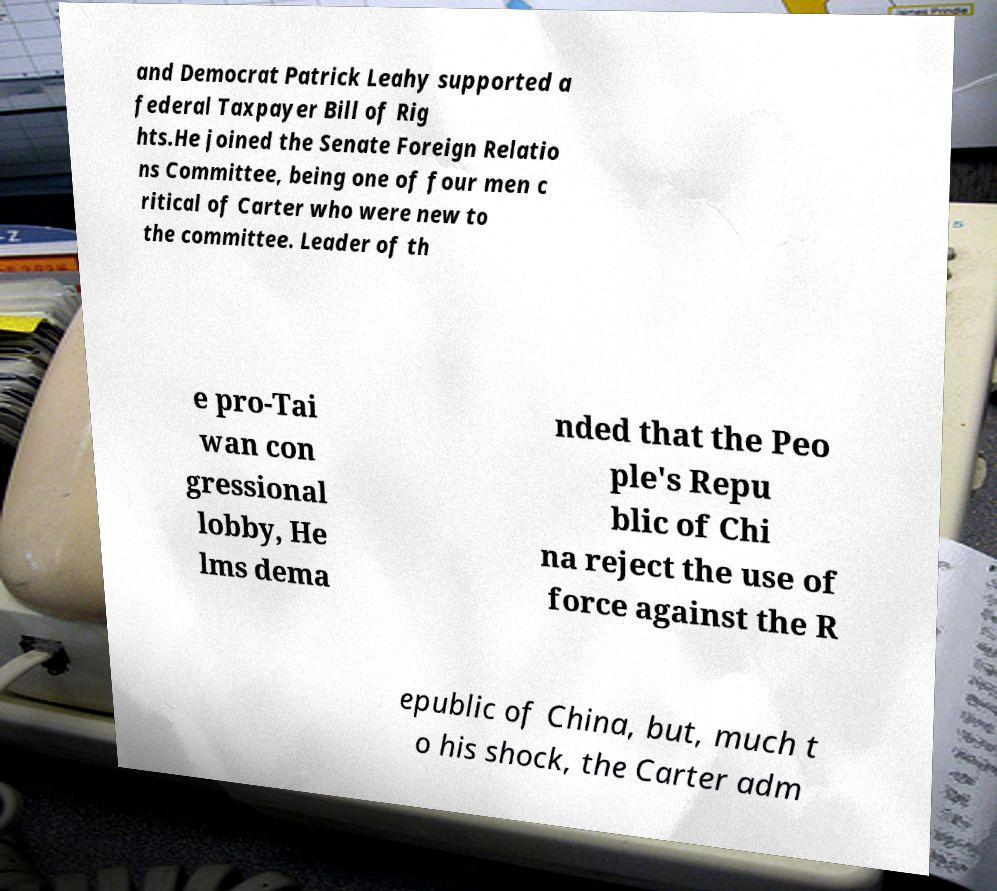Could you extract and type out the text from this image? and Democrat Patrick Leahy supported a federal Taxpayer Bill of Rig hts.He joined the Senate Foreign Relatio ns Committee, being one of four men c ritical of Carter who were new to the committee. Leader of th e pro-Tai wan con gressional lobby, He lms dema nded that the Peo ple's Repu blic of Chi na reject the use of force against the R epublic of China, but, much t o his shock, the Carter adm 